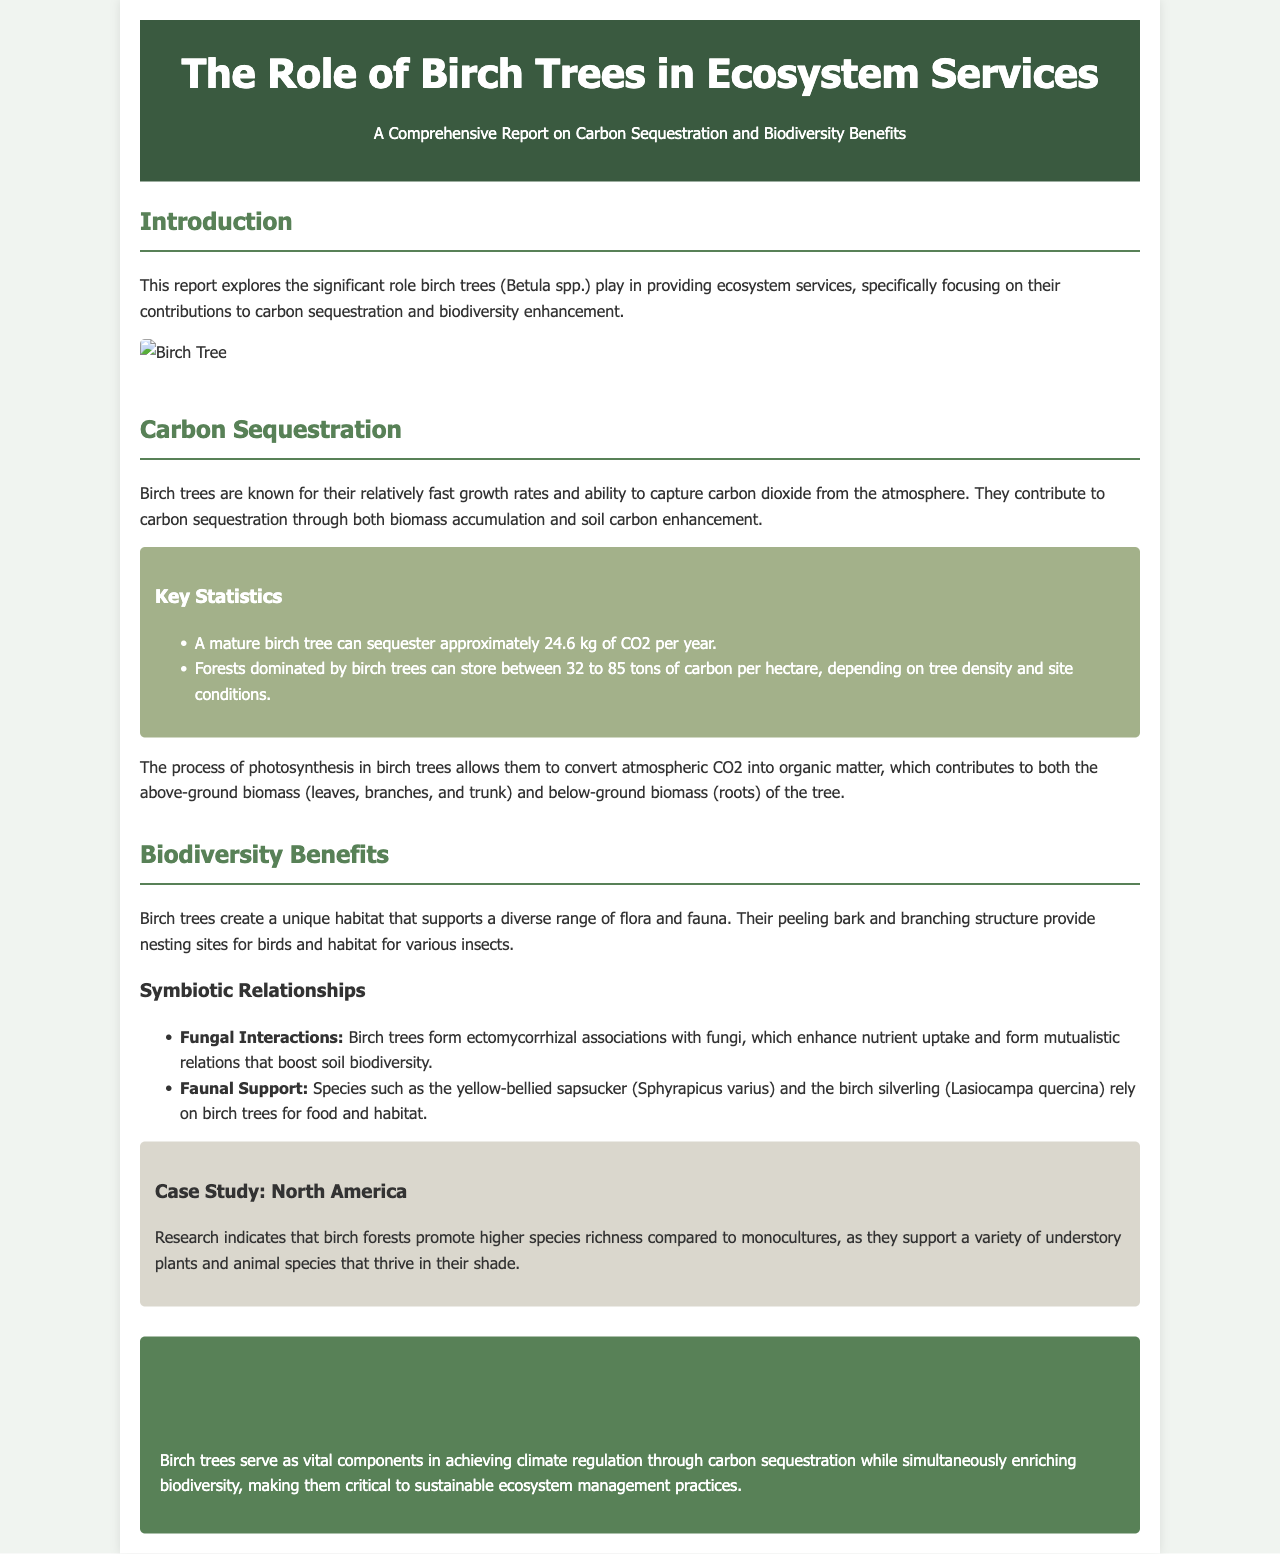What are birch trees known for? Birch trees are known for their relatively fast growth rates and ability to capture carbon dioxide from the atmosphere.
Answer: Fast growth rates and carbon capture How much CO2 can a mature birch tree sequester per year? A mature birch tree can sequester approximately 24.6 kg of CO2 per year.
Answer: 24.6 kg What do birch trees support in terms of biodiversity? Birch trees create a unique habitat that supports a diverse range of flora and fauna.
Answer: Flora and fauna What type of associations do birch trees form with fungi? Birch trees form ectomycorrhizal associations with fungi, enhancing nutrient uptake.
Answer: Ectomycorrhizal associations What is the carbon storage range for birch-dominated forests per hectare? Forests dominated by birch trees can store between 32 to 85 tons of carbon per hectare.
Answer: 32 to 85 tons Which bird species is mentioned as relying on birch trees? The yellow-bellied sapsucker is mentioned as relying on birch trees for food and habitat.
Answer: Yellow-bellied sapsucker What does the case study in North America indicate about birch forests? The case study indicates that birch forests promote higher species richness compared to monocultures.
Answer: Higher species richness What two ecosystem services do birch trees help achieve? Birch trees serve as vital components in achieving climate regulation and enriching biodiversity.
Answer: Climate regulation and biodiversity enrichment 